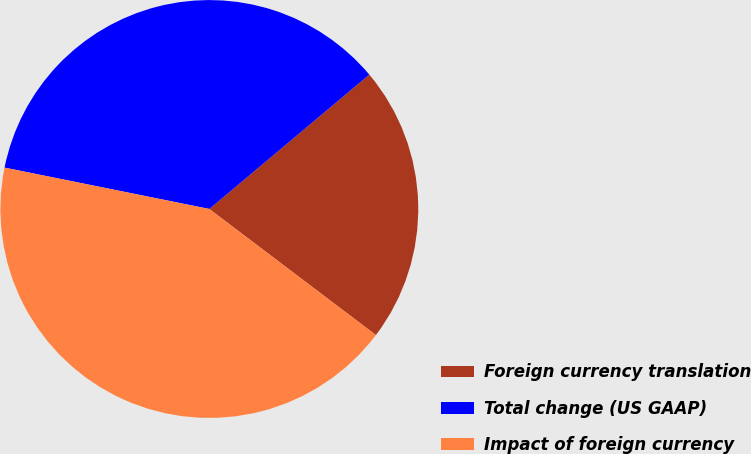Convert chart to OTSL. <chart><loc_0><loc_0><loc_500><loc_500><pie_chart><fcel>Foreign currency translation<fcel>Total change (US GAAP)<fcel>Impact of foreign currency<nl><fcel>21.43%<fcel>35.71%<fcel>42.86%<nl></chart> 